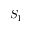<formula> <loc_0><loc_0><loc_500><loc_500>S _ { 1 }</formula> 